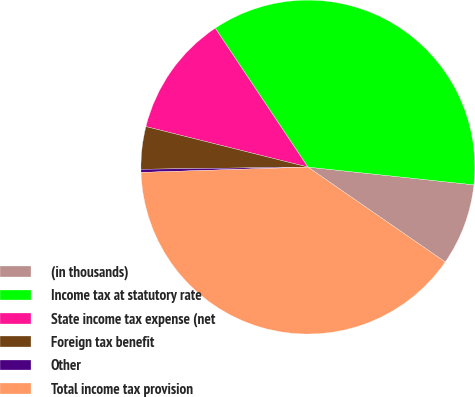<chart> <loc_0><loc_0><loc_500><loc_500><pie_chart><fcel>(in thousands)<fcel>Income tax at statutory rate<fcel>State income tax expense (net<fcel>Foreign tax benefit<fcel>Other<fcel>Total income tax provision<nl><fcel>7.93%<fcel>36.06%<fcel>11.74%<fcel>4.11%<fcel>0.3%<fcel>39.87%<nl></chart> 